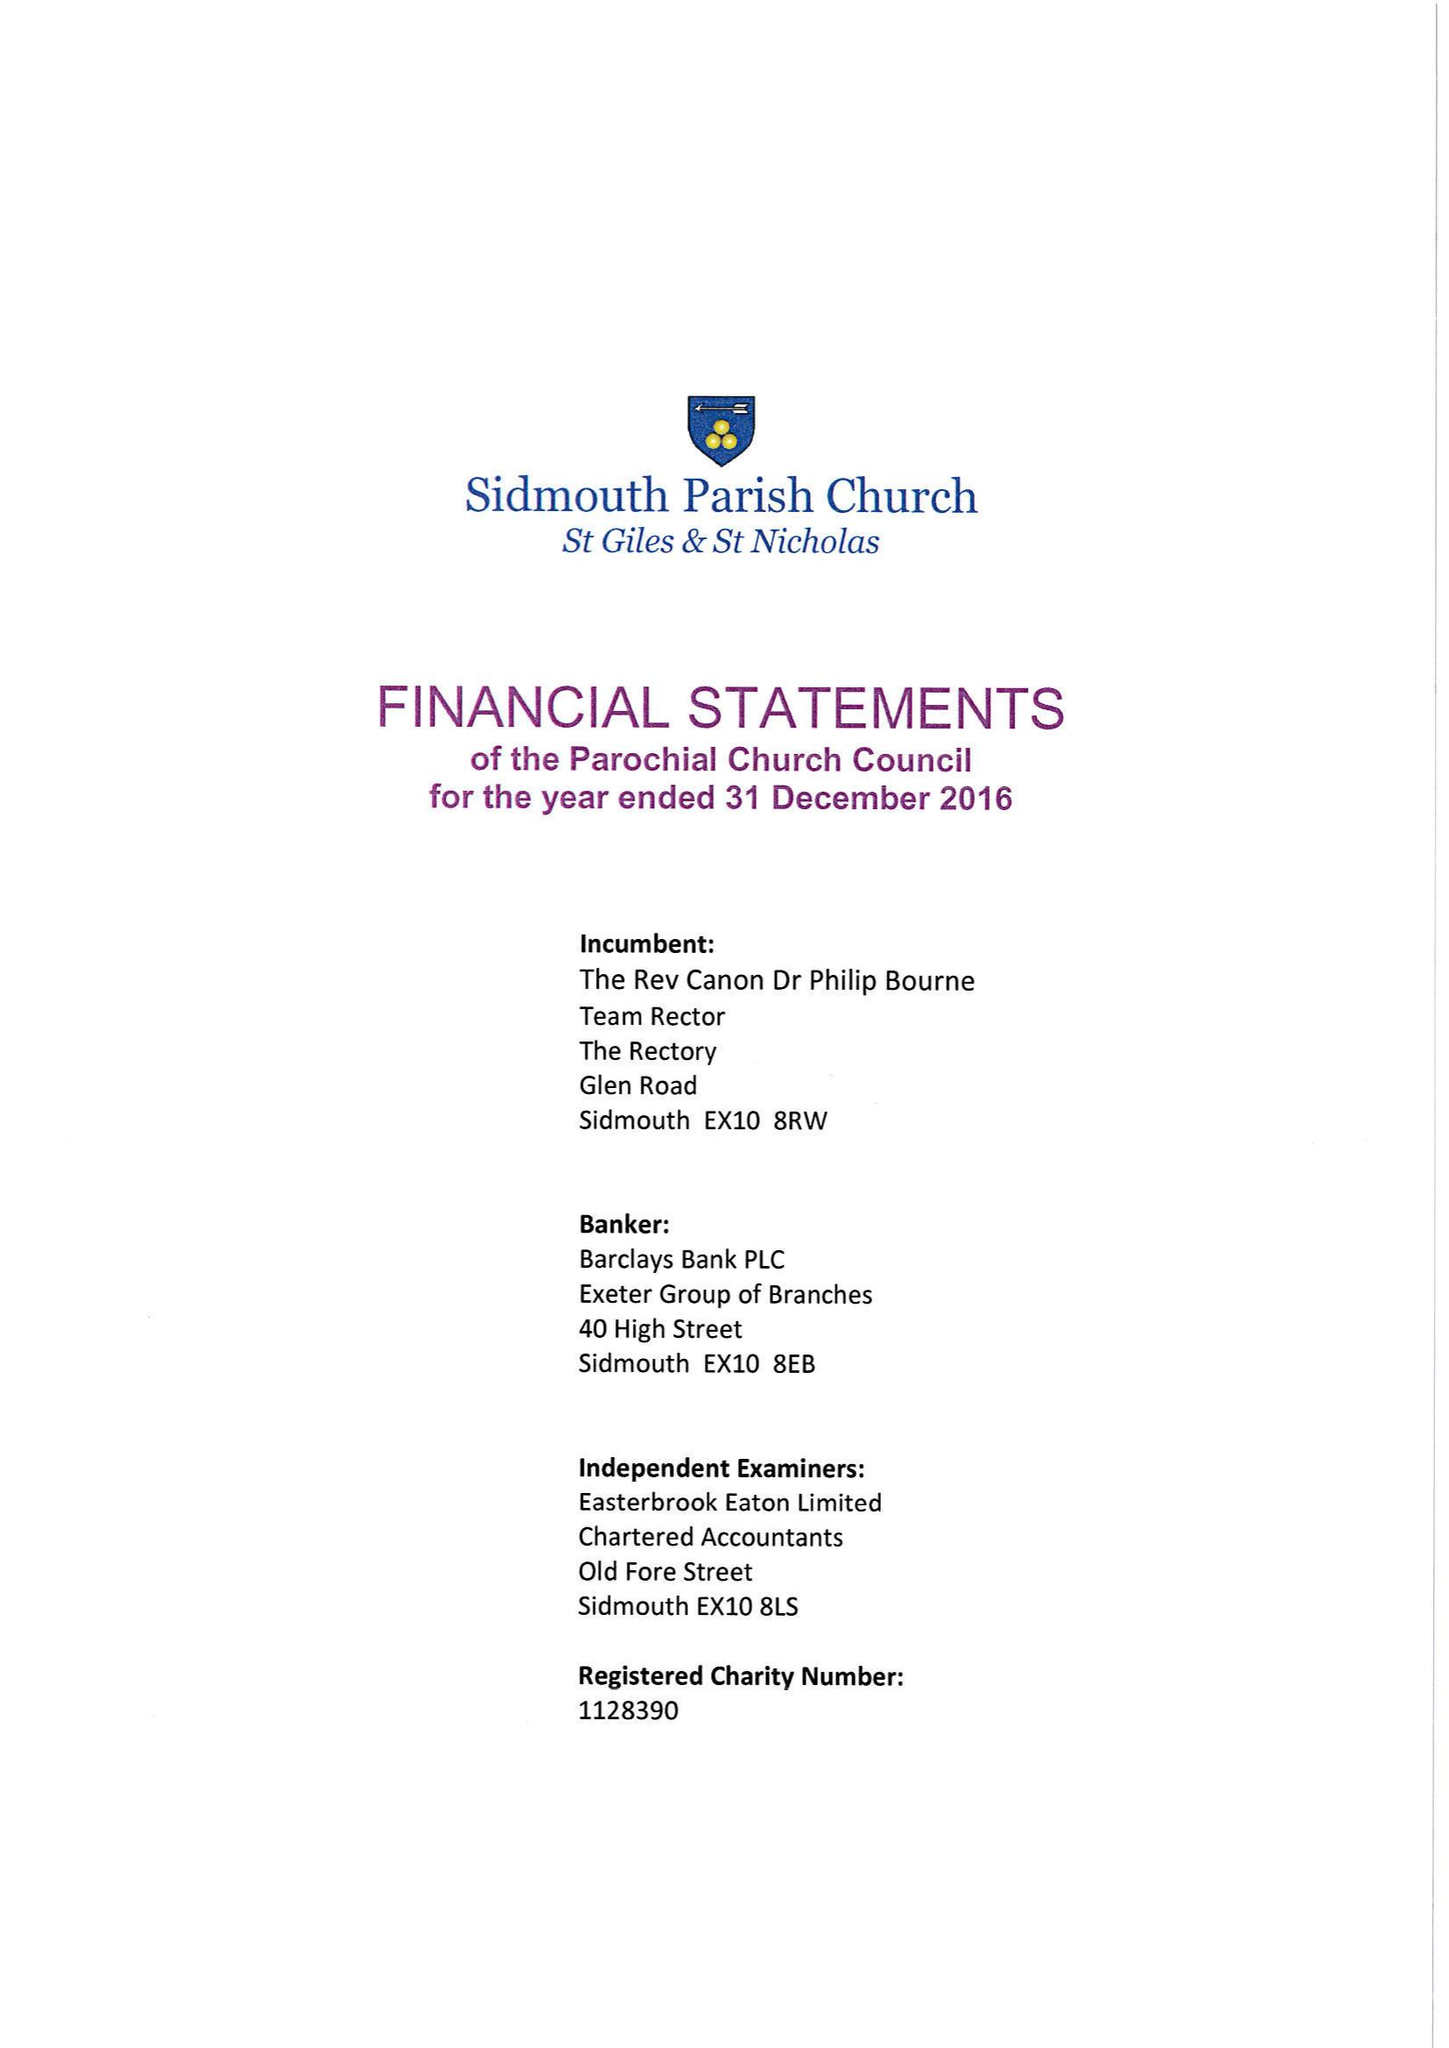What is the value for the spending_annually_in_british_pounds?
Answer the question using a single word or phrase. 304485.00 